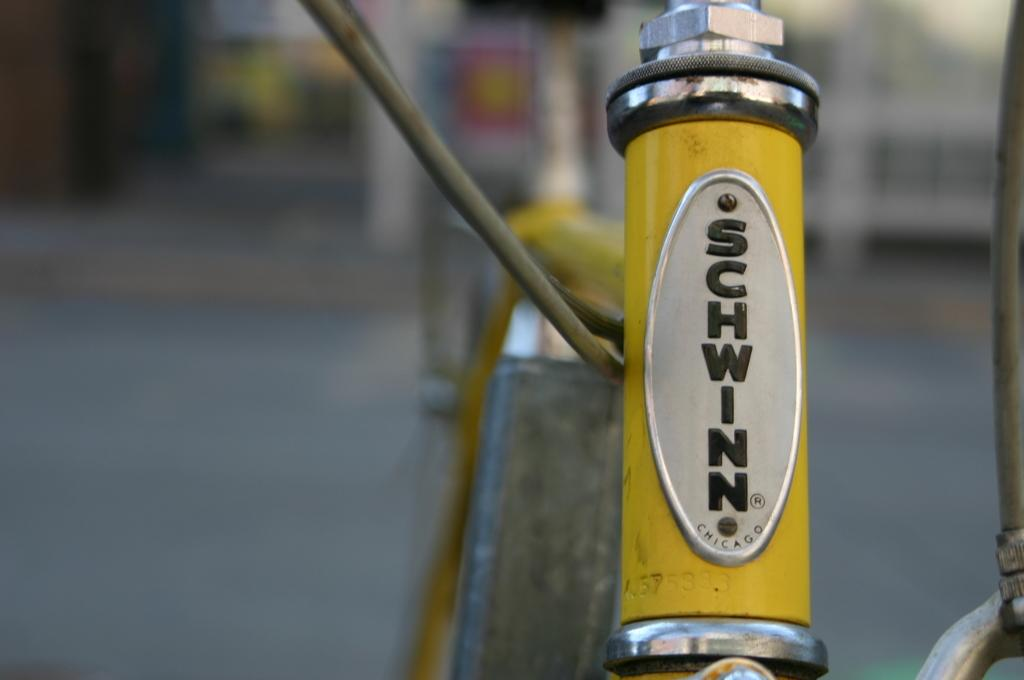What type of material is the object in the image made of? The object in the image is made up of metal. Does the object have any identifying features? Yes, the object has a nameplate. What color is the nameplate on the object? The nameplate is in yellow color. How would you describe the background of the image? The background of the image is blurred. What type of mask is being worn by the person in the image? There is no person or mask present in the image; it features a metal object with a yellow nameplate and a blurred background. 